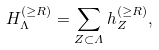<formula> <loc_0><loc_0><loc_500><loc_500>H _ { \Lambda } ^ { ( \geq R ) } = \sum _ { Z \subset \varLambda } h _ { Z } ^ { ( \geq R ) } ,</formula> 